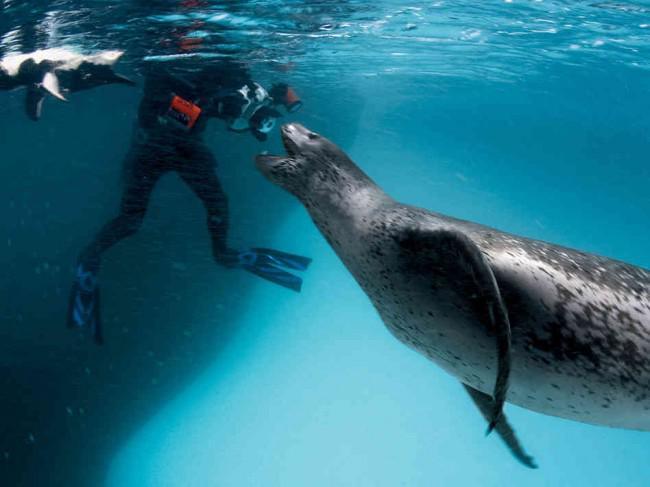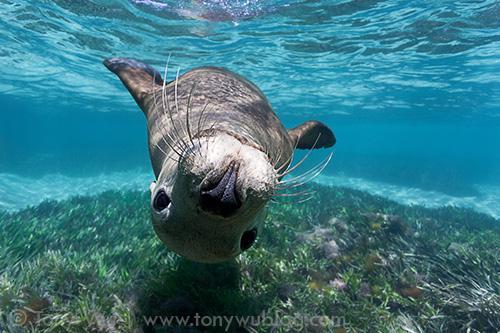The first image is the image on the left, the second image is the image on the right. For the images shown, is this caption "One of the images in the pair contains a lone seal without any penguins." true? Answer yes or no. Yes. 